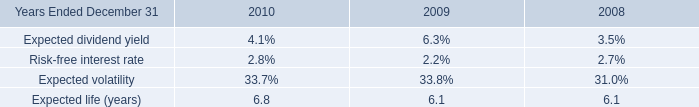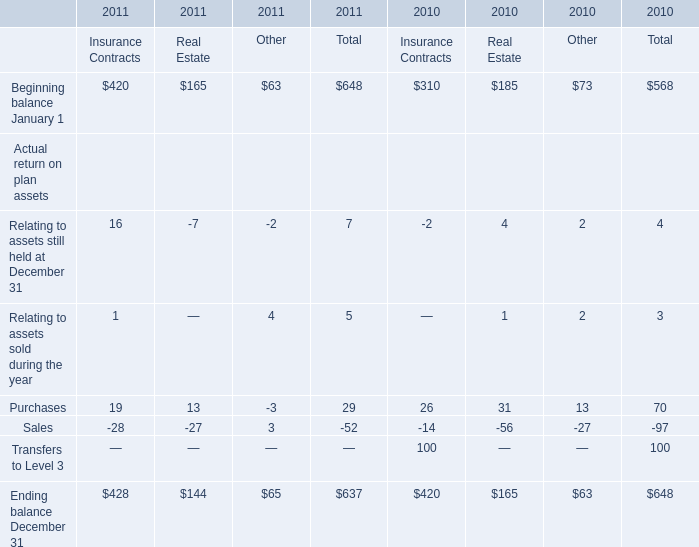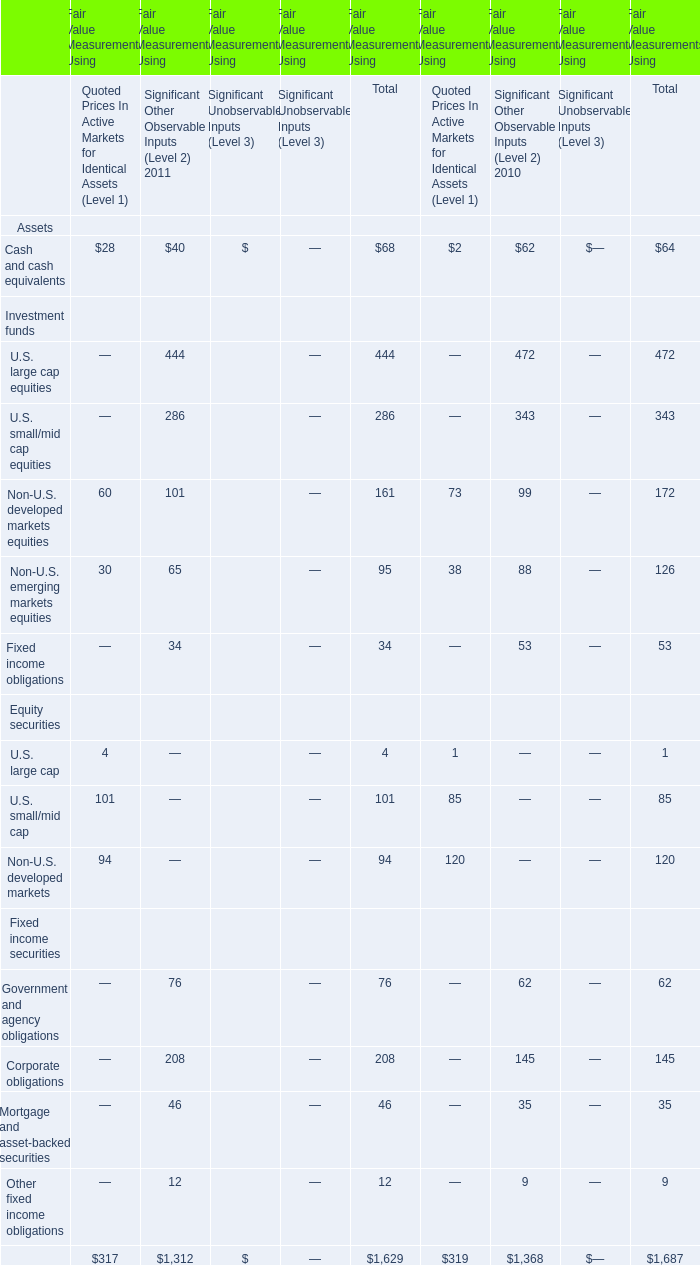If the total amount of the corporate obligations for Fair Value Measurements Using develops with the same growth rate in 2011, what will it reach in 2012? 
Computations: (208 * (1 + ((208 - 145) / 145)))
Answer: 298.37241. 